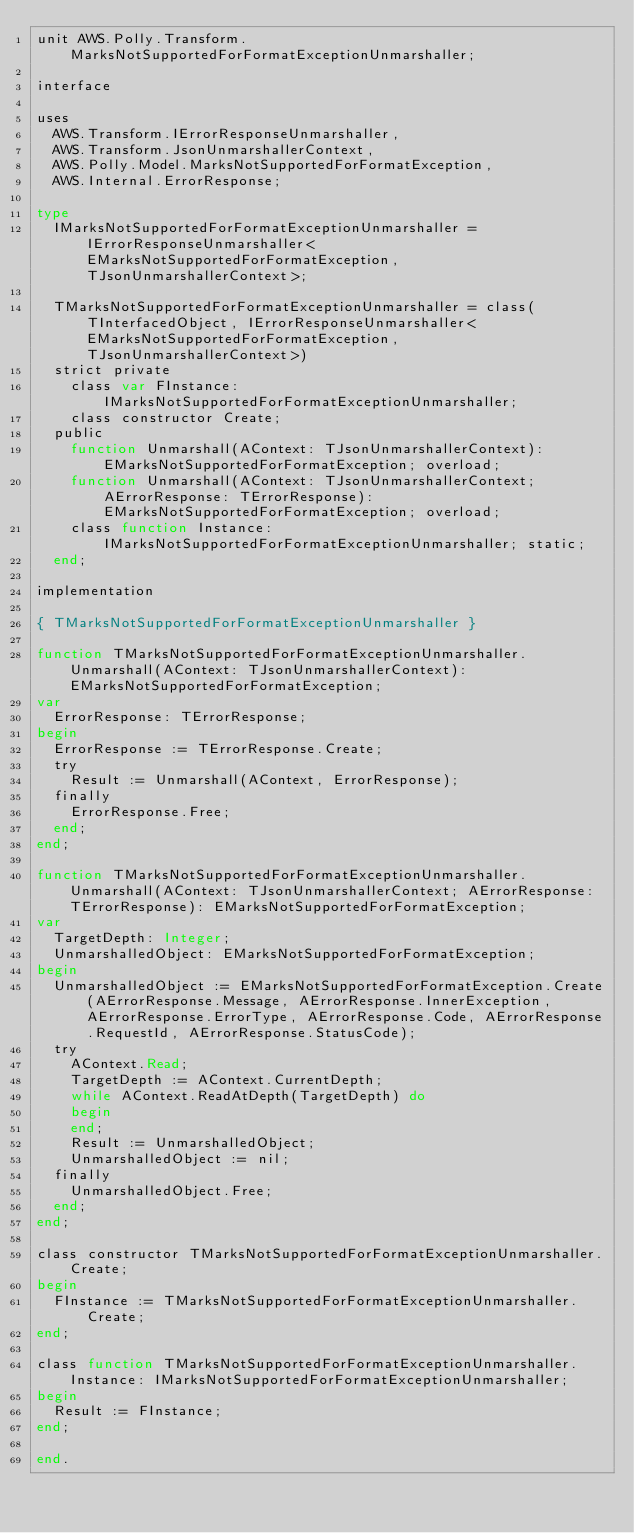Convert code to text. <code><loc_0><loc_0><loc_500><loc_500><_Pascal_>unit AWS.Polly.Transform.MarksNotSupportedForFormatExceptionUnmarshaller;

interface

uses
  AWS.Transform.IErrorResponseUnmarshaller, 
  AWS.Transform.JsonUnmarshallerContext, 
  AWS.Polly.Model.MarksNotSupportedForFormatException, 
  AWS.Internal.ErrorResponse;

type
  IMarksNotSupportedForFormatExceptionUnmarshaller = IErrorResponseUnmarshaller<EMarksNotSupportedForFormatException, TJsonUnmarshallerContext>;
  
  TMarksNotSupportedForFormatExceptionUnmarshaller = class(TInterfacedObject, IErrorResponseUnmarshaller<EMarksNotSupportedForFormatException, TJsonUnmarshallerContext>)
  strict private
    class var FInstance: IMarksNotSupportedForFormatExceptionUnmarshaller;
    class constructor Create;
  public
    function Unmarshall(AContext: TJsonUnmarshallerContext): EMarksNotSupportedForFormatException; overload;
    function Unmarshall(AContext: TJsonUnmarshallerContext; AErrorResponse: TErrorResponse): EMarksNotSupportedForFormatException; overload;
    class function Instance: IMarksNotSupportedForFormatExceptionUnmarshaller; static;
  end;
  
implementation

{ TMarksNotSupportedForFormatExceptionUnmarshaller }

function TMarksNotSupportedForFormatExceptionUnmarshaller.Unmarshall(AContext: TJsonUnmarshallerContext): EMarksNotSupportedForFormatException;
var
  ErrorResponse: TErrorResponse;
begin
  ErrorResponse := TErrorResponse.Create;
  try
    Result := Unmarshall(AContext, ErrorResponse);
  finally
    ErrorResponse.Free;
  end;
end;

function TMarksNotSupportedForFormatExceptionUnmarshaller.Unmarshall(AContext: TJsonUnmarshallerContext; AErrorResponse: TErrorResponse): EMarksNotSupportedForFormatException;
var
  TargetDepth: Integer;
  UnmarshalledObject: EMarksNotSupportedForFormatException;
begin
  UnmarshalledObject := EMarksNotSupportedForFormatException.Create(AErrorResponse.Message, AErrorResponse.InnerException, AErrorResponse.ErrorType, AErrorResponse.Code, AErrorResponse.RequestId, AErrorResponse.StatusCode);
  try
    AContext.Read;
    TargetDepth := AContext.CurrentDepth;
    while AContext.ReadAtDepth(TargetDepth) do
    begin
    end;
    Result := UnmarshalledObject;
    UnmarshalledObject := nil;
  finally
    UnmarshalledObject.Free;
  end;
end;

class constructor TMarksNotSupportedForFormatExceptionUnmarshaller.Create;
begin
  FInstance := TMarksNotSupportedForFormatExceptionUnmarshaller.Create;
end;

class function TMarksNotSupportedForFormatExceptionUnmarshaller.Instance: IMarksNotSupportedForFormatExceptionUnmarshaller;
begin
  Result := FInstance;
end;

end.
</code> 